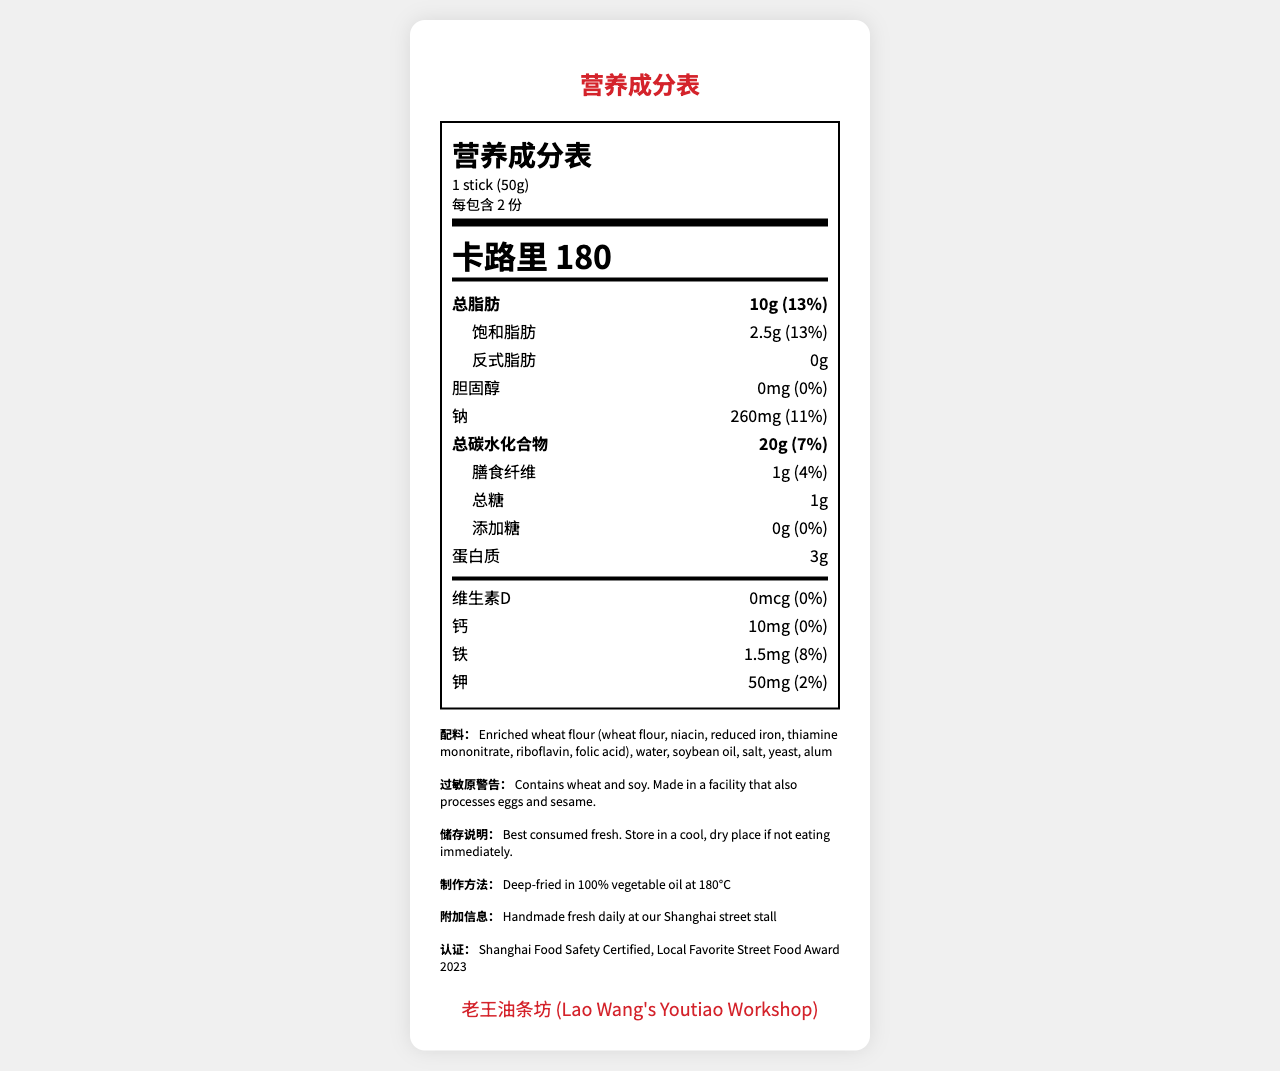What is the serving size for you tiao (Chinese fried dough sticks)? The document specifies the serving size as "1 stick (50g)".
Answer: 1 stick (50g) How many servings are there in one container? The document states there are 2 servings per container.
Answer: 2 How many calories are there in one serving of you tiao? The document lists the calorie content as 180 calories per serving.
Answer: 180 What percentage of the daily value does the total fat content of one serving represent? The document provides that the total fat content is 10g, which is 13% of the daily value.
Answer: 13% Are there any trans fats in one serving of you tiao? Yes or No The document states the trans fat content as "0g".
Answer: No Which mineral has the highest percentage of the daily value in one serving of you tiao? A. Calcium B. Iron C. Potassium The document lists iron at 8% daily value, calcium at 0%, and potassium at 2%.
Answer: B. Iron What is the total carbohydrate content in one serving of you tiao? The document states the total carbohydrate content as 20g.
Answer: 20g List any allergens mentioned in the document. The document warns that the product contains wheat and soy.
Answer: Wheat and soy How should you tiao be stored if not eaten immediately? The storage instructions in the document advise to store in a cool, dry place.
Answer: Store in a cool, dry place What is the protein content in one serving of you tiao? The document states that one serving contains 3g of protein.
Answer: 3g What is the amount of dietary fiber in one serving and its percentage of the daily value? The document lists dietary fiber as 1g, which is 4% of the daily value.
Answer: 1g, 4% Which award did Lao Wang's Youtiao Workshop win in 2023? A. Local Favorite Street Food Award 2023 B. Best Breakfast Item Award 2023 C. Street Vendor of the Year 2023 The document lists "Local Favorite Street Food Award 2023" as one of the certifications.
Answer: A. Local Favorite Street Food Award 2023 Does the document provide information on the amount of added sugars in one serving? The document states that the added sugars amount is 0g and the percent daily value is 0%.
Answer: Yes Is the you tiao deep-fried? Yes or No The preparation method in the document specifies that it is deep-fried in 100% vegetable oil at 180°C.
Answer: Yes Summarize the main nutritional information of you tiao from Lao Wang's Youtiao Workshop. The summary includes all major nutritional information items such as serving size, calories, macronutrients, and micronutrients, while also addressing storage instructions and allergen warnings. The brand's additional certifications are also noted.
Answer: The nutrition facts label for you tiao from Lao Wang's Youtiao Workshop shows that one serving size is 1 stick (50g) with 180 calories. It contains 10g of total fat (13% daily value), 2.5g of saturated fat, 0g trans fat, 0mg cholesterol, 260mg sodium, 20g total carbohydrate (7% daily value), 1g dietary fiber (4% daily value), 1g total sugars, 0g added sugars, and 3g of protein. It also provides information on vitamins and minerals like calcium (10mg, 0%), iron (1.5mg, 8%), and potassium (50mg, 2%). The product contains wheat and soy and should be stored in a cool, dry place if not eaten immediately. Which ingredient is not listed in the ingredients section? The document lists "Enriched wheat flour, water, soybean oil, salt, yeast, alum" as ingredients, but without further context, it's impossible to know if any ingredient is missing.
Answer: Not enough information 